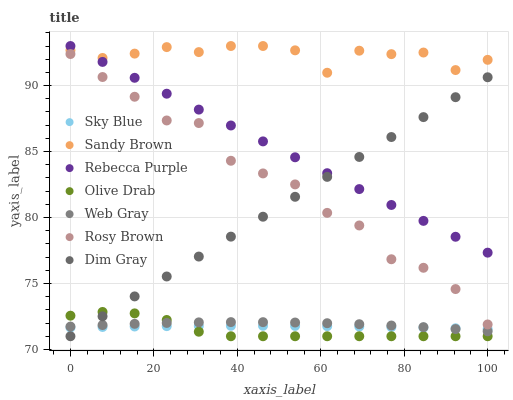Does Olive Drab have the minimum area under the curve?
Answer yes or no. Yes. Does Sandy Brown have the maximum area under the curve?
Answer yes or no. Yes. Does Rosy Brown have the minimum area under the curve?
Answer yes or no. No. Does Rosy Brown have the maximum area under the curve?
Answer yes or no. No. Is Rebecca Purple the smoothest?
Answer yes or no. Yes. Is Rosy Brown the roughest?
Answer yes or no. Yes. Is Dim Gray the smoothest?
Answer yes or no. No. Is Dim Gray the roughest?
Answer yes or no. No. Does Dim Gray have the lowest value?
Answer yes or no. Yes. Does Rosy Brown have the lowest value?
Answer yes or no. No. Does Sandy Brown have the highest value?
Answer yes or no. Yes. Does Rosy Brown have the highest value?
Answer yes or no. No. Is Web Gray less than Rebecca Purple?
Answer yes or no. Yes. Is Rosy Brown greater than Sky Blue?
Answer yes or no. Yes. Does Olive Drab intersect Web Gray?
Answer yes or no. Yes. Is Olive Drab less than Web Gray?
Answer yes or no. No. Is Olive Drab greater than Web Gray?
Answer yes or no. No. Does Web Gray intersect Rebecca Purple?
Answer yes or no. No. 